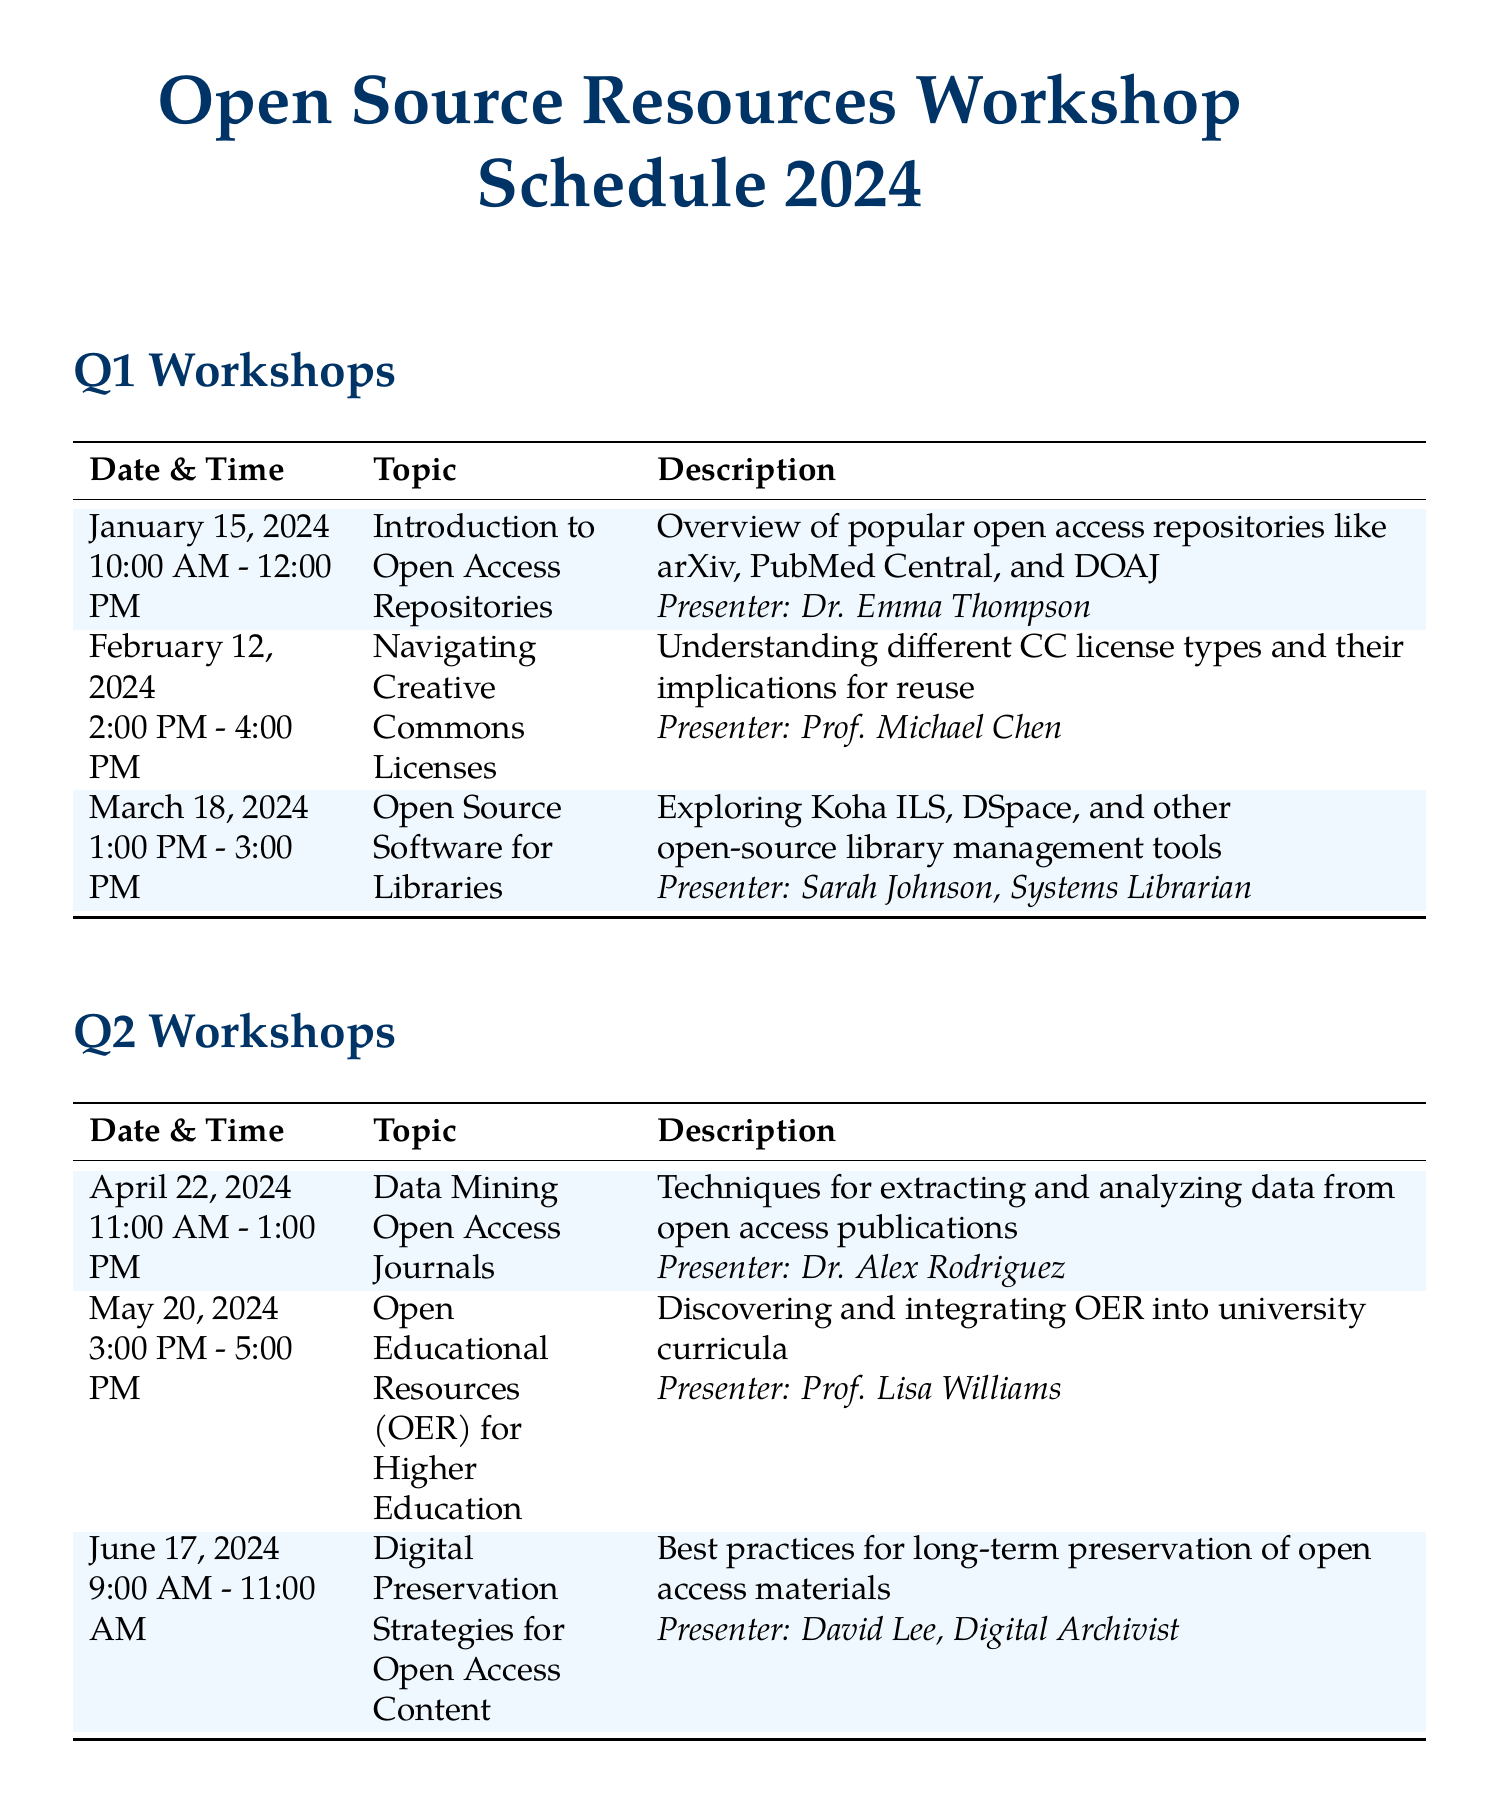What is the topic of the first workshop scheduled in Q1? The first workshop in Q1 is focused on introducing open access repositories, which is specified in the workshop schedule.
Answer: Introduction to Open Access Repositories Who is the presenter for the workshop on Digital Preservation Strategies for Open Access Content? The schedule lists David Lee as the presenter for this specific workshop in Q2.
Answer: David Lee What is the duration of the Metadata Standards for Open Access Repositories workshop? The schedule indicates that this workshop takes place from 2:00 PM to 4:00 PM, which totals 2 hours.
Answer: 2 hours When is the Open Access Week Special workshop scheduled? The schedule shows that this workshop is scheduled for October 21, 2024, in Q4.
Answer: October 21, 2024 How many workshops are scheduled in Q3? The schedule details three sessions listed for Q3 workshops, focusing on various topics.
Answer: 3 What time does the workshop on Open Educational Resources for Higher Education start? According to the schedule, this workshop starts at 3:00 PM as listed under Q2.
Answer: 3:00 PM Which topic is covered in the workshop on June 17, 2024? The workshop scheduled on this date is focused on digital preservation strategies, as seen in the Q2 section.
Answer: Digital Preservation Strategies for Open Access Content What is the purpose of the Year-End Review workshop? The schedule describes this workshop as showcasing successful implementations, indicating its purpose for reflection on the year.
Answer: Showcasing successful implementations of open source resources in research and education 